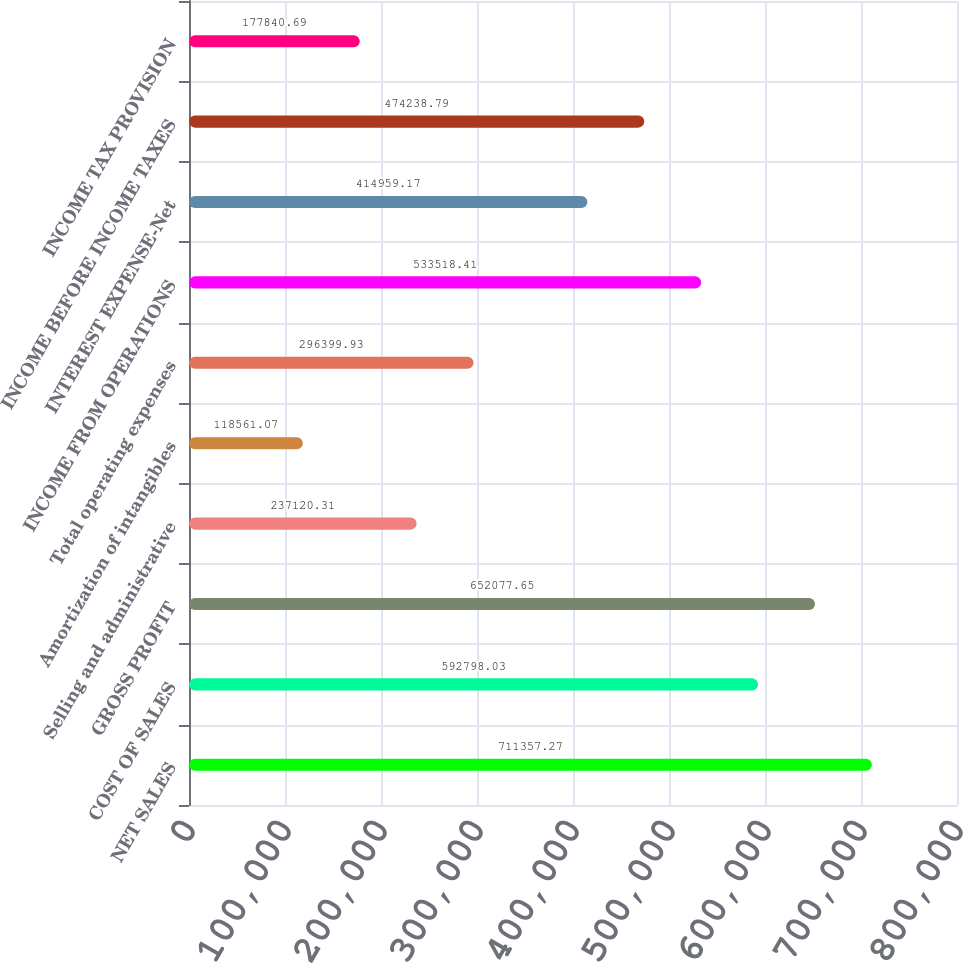Convert chart to OTSL. <chart><loc_0><loc_0><loc_500><loc_500><bar_chart><fcel>NET SALES<fcel>COST OF SALES<fcel>GROSS PROFIT<fcel>Selling and administrative<fcel>Amortization of intangibles<fcel>Total operating expenses<fcel>INCOME FROM OPERATIONS<fcel>INTEREST EXPENSE-Net<fcel>INCOME BEFORE INCOME TAXES<fcel>INCOME TAX PROVISION<nl><fcel>711357<fcel>592798<fcel>652078<fcel>237120<fcel>118561<fcel>296400<fcel>533518<fcel>414959<fcel>474239<fcel>177841<nl></chart> 